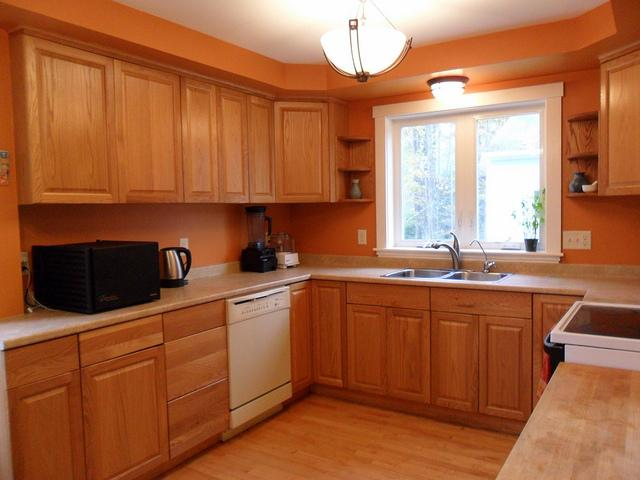What heats the stove for cooking?

Choices:
A) wood
B) natural gas
C) coal
D) electricity electricity 